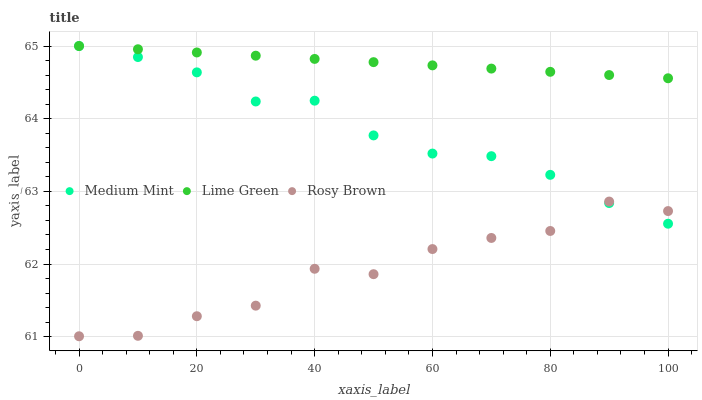Does Rosy Brown have the minimum area under the curve?
Answer yes or no. Yes. Does Lime Green have the maximum area under the curve?
Answer yes or no. Yes. Does Lime Green have the minimum area under the curve?
Answer yes or no. No. Does Rosy Brown have the maximum area under the curve?
Answer yes or no. No. Is Lime Green the smoothest?
Answer yes or no. Yes. Is Rosy Brown the roughest?
Answer yes or no. Yes. Is Rosy Brown the smoothest?
Answer yes or no. No. Is Lime Green the roughest?
Answer yes or no. No. Does Rosy Brown have the lowest value?
Answer yes or no. Yes. Does Lime Green have the lowest value?
Answer yes or no. No. Does Lime Green have the highest value?
Answer yes or no. Yes. Does Rosy Brown have the highest value?
Answer yes or no. No. Is Rosy Brown less than Lime Green?
Answer yes or no. Yes. Is Lime Green greater than Rosy Brown?
Answer yes or no. Yes. Does Medium Mint intersect Lime Green?
Answer yes or no. Yes. Is Medium Mint less than Lime Green?
Answer yes or no. No. Is Medium Mint greater than Lime Green?
Answer yes or no. No. Does Rosy Brown intersect Lime Green?
Answer yes or no. No. 